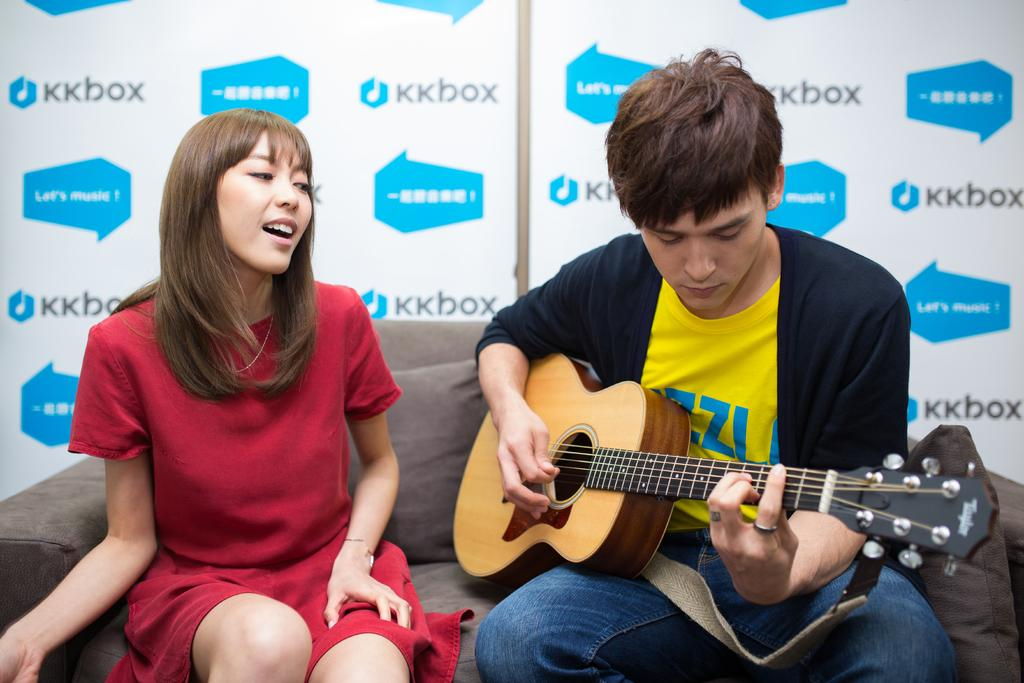Who is present in the image? There is a woman and a man in the image. What is the woman wearing? The woman is wearing a red shirt. Where are the woman and man sitting? They are both sitting on a couch. What is the man doing in the image? The man is playing a guitar. What can be seen in the background of the image? There is a hoarding in the background of the image. What type of ink is the woman using to write on the guitar? There is no indication in the image that the woman is writing on the guitar, nor is there any ink present. 